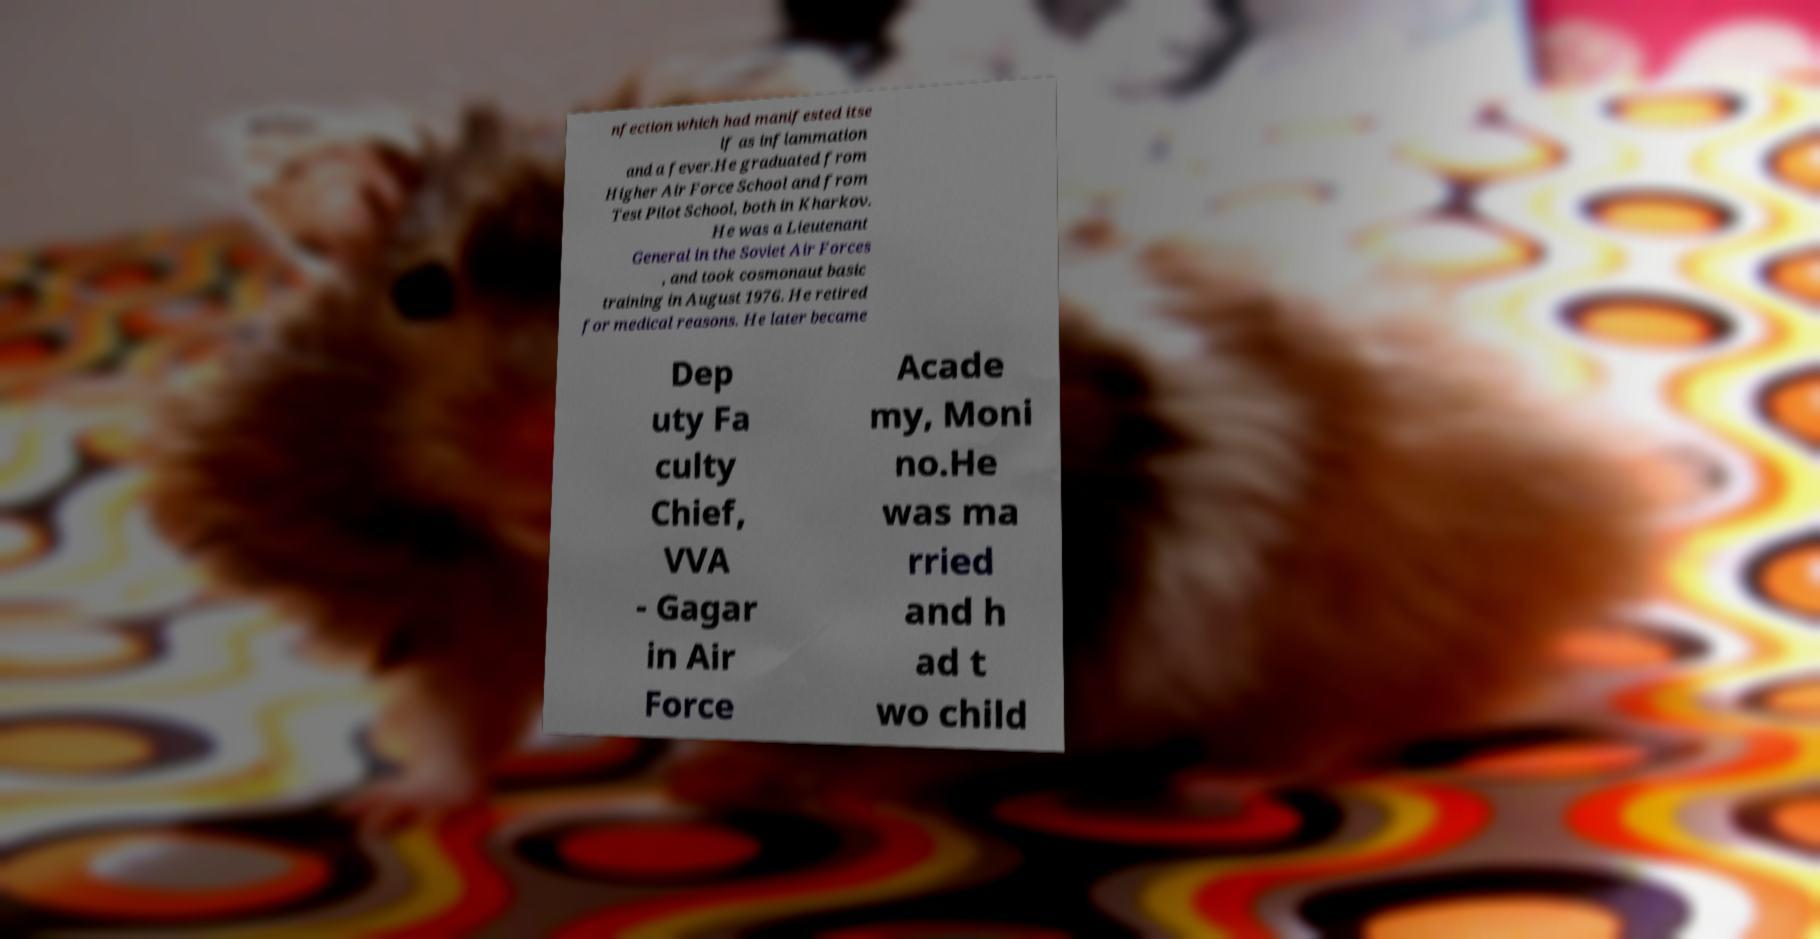What messages or text are displayed in this image? I need them in a readable, typed format. nfection which had manifested itse lf as inflammation and a fever.He graduated from Higher Air Force School and from Test Pilot School, both in Kharkov. He was a Lieutenant General in the Soviet Air Forces , and took cosmonaut basic training in August 1976. He retired for medical reasons. He later became Dep uty Fa culty Chief, VVA - Gagar in Air Force Acade my, Moni no.He was ma rried and h ad t wo child 